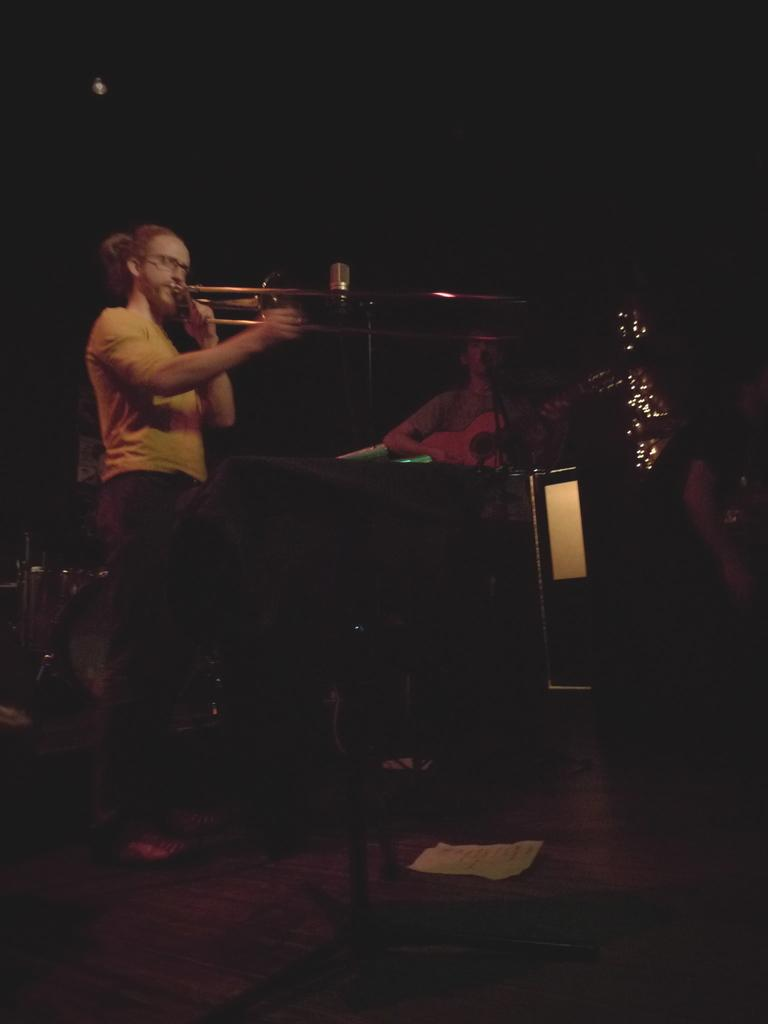What is the main activity of the person in the image? There is a person playing a musical instrument in the image. What is positioned in front of the person playing the musical instrument? There is a microphone in front of the person playing the musical instrument. Can you identify another person in the image and their activity? Yes, there is another person playing a guitar in the image. What type of plants can be seen growing near the person playing the guitar? There are no plants visible in the image; it features two people playing musical instruments. 